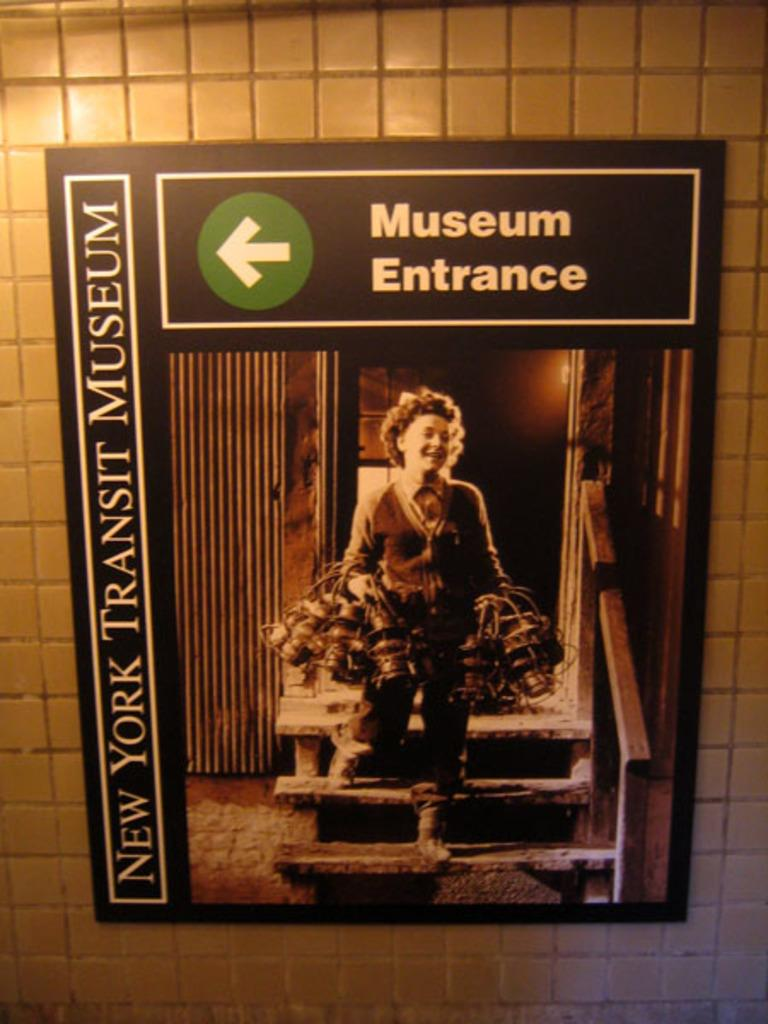<image>
Provide a brief description of the given image. A white arrow points towards the museum entrance 